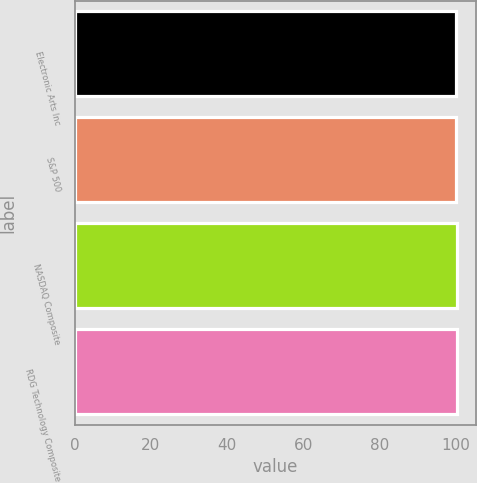Convert chart to OTSL. <chart><loc_0><loc_0><loc_500><loc_500><bar_chart><fcel>Electronic Arts Inc<fcel>S&P 500<fcel>NASDAQ Composite<fcel>RDG Technology Composite<nl><fcel>100<fcel>100.1<fcel>100.2<fcel>100.3<nl></chart> 